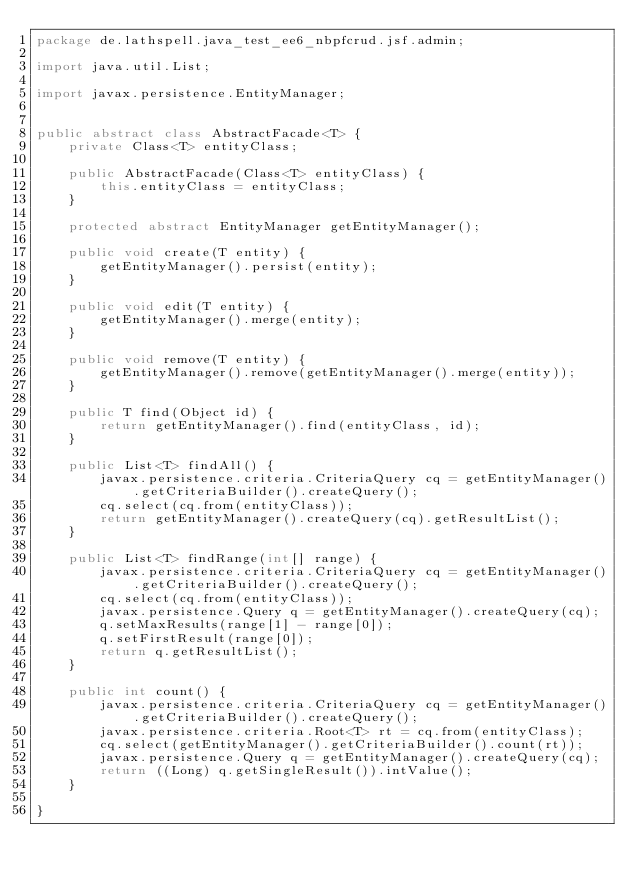<code> <loc_0><loc_0><loc_500><loc_500><_Java_>package de.lathspell.java_test_ee6_nbpfcrud.jsf.admin;

import java.util.List;

import javax.persistence.EntityManager;


public abstract class AbstractFacade<T> {
    private Class<T> entityClass;

    public AbstractFacade(Class<T> entityClass) {
        this.entityClass = entityClass;
    }

    protected abstract EntityManager getEntityManager();

    public void create(T entity) {
        getEntityManager().persist(entity);
    }

    public void edit(T entity) {
        getEntityManager().merge(entity);
    }

    public void remove(T entity) {
        getEntityManager().remove(getEntityManager().merge(entity));
    }

    public T find(Object id) {
        return getEntityManager().find(entityClass, id);
    }

    public List<T> findAll() {
        javax.persistence.criteria.CriteriaQuery cq = getEntityManager().getCriteriaBuilder().createQuery();
        cq.select(cq.from(entityClass));
        return getEntityManager().createQuery(cq).getResultList();
    }

    public List<T> findRange(int[] range) {
        javax.persistence.criteria.CriteriaQuery cq = getEntityManager().getCriteriaBuilder().createQuery();
        cq.select(cq.from(entityClass));
        javax.persistence.Query q = getEntityManager().createQuery(cq);
        q.setMaxResults(range[1] - range[0]);
        q.setFirstResult(range[0]);
        return q.getResultList();
    }

    public int count() {
        javax.persistence.criteria.CriteriaQuery cq = getEntityManager().getCriteriaBuilder().createQuery();
        javax.persistence.criteria.Root<T> rt = cq.from(entityClass);
        cq.select(getEntityManager().getCriteriaBuilder().count(rt));
        javax.persistence.Query q = getEntityManager().createQuery(cq);
        return ((Long) q.getSingleResult()).intValue();
    }

}
</code> 